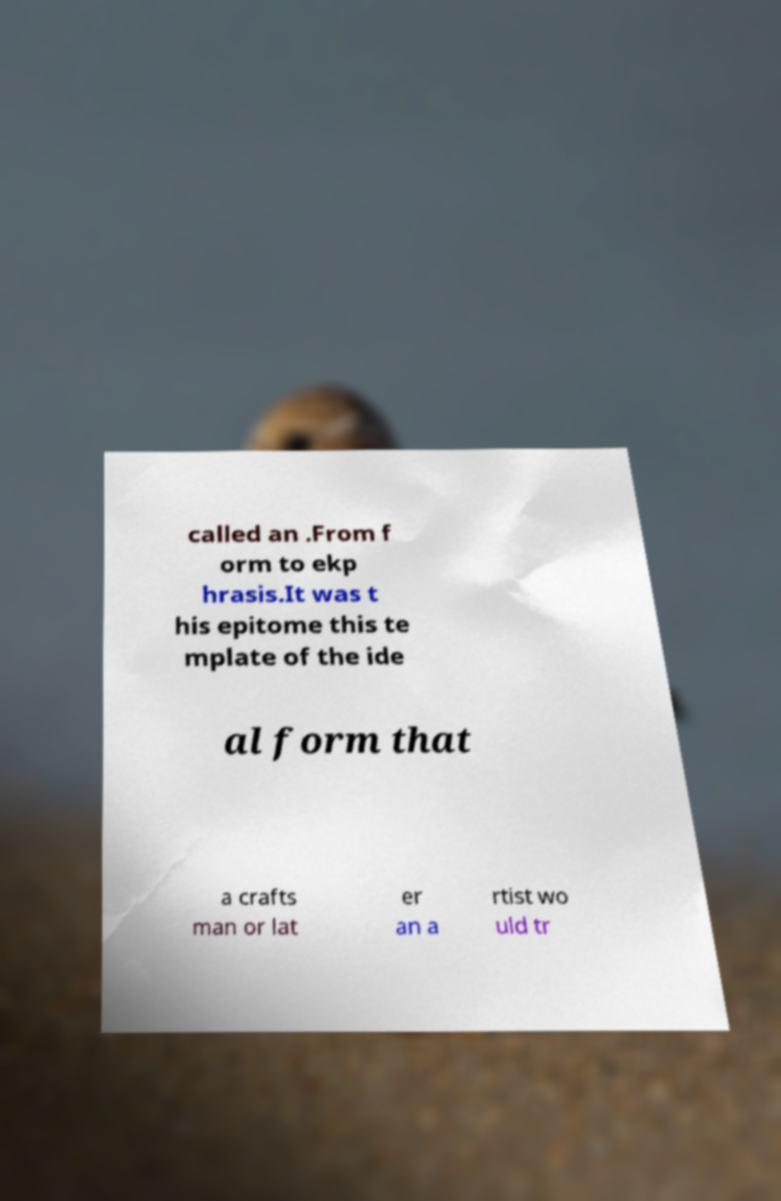For documentation purposes, I need the text within this image transcribed. Could you provide that? called an .From f orm to ekp hrasis.It was t his epitome this te mplate of the ide al form that a crafts man or lat er an a rtist wo uld tr 